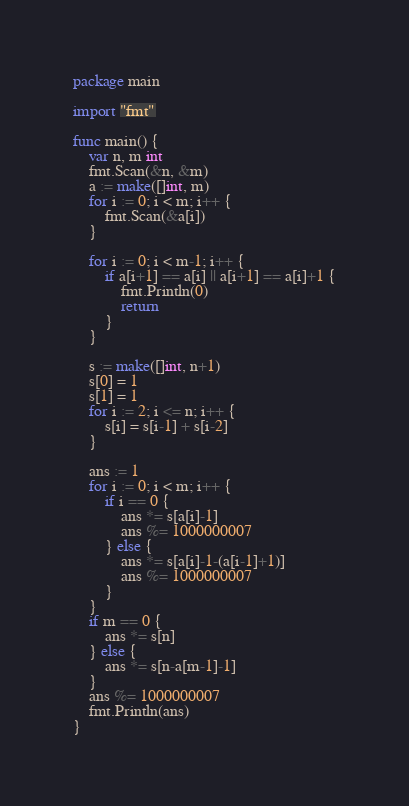Convert code to text. <code><loc_0><loc_0><loc_500><loc_500><_Go_>package main

import "fmt"

func main() {
	var n, m int
	fmt.Scan(&n, &m)
	a := make([]int, m)
	for i := 0; i < m; i++ {
		fmt.Scan(&a[i])
	}

	for i := 0; i < m-1; i++ {
		if a[i+1] == a[i] || a[i+1] == a[i]+1 {
			fmt.Println(0)
			return
		}
	}

	s := make([]int, n+1)
	s[0] = 1
	s[1] = 1
	for i := 2; i <= n; i++ {
		s[i] = s[i-1] + s[i-2]
	}

	ans := 1
	for i := 0; i < m; i++ {
		if i == 0 {
			ans *= s[a[i]-1]
			ans %= 1000000007
		} else {
			ans *= s[a[i]-1-(a[i-1]+1)]
			ans %= 1000000007
		}
	}
	if m == 0 {
		ans *= s[n]
	} else {
		ans *= s[n-a[m-1]-1]
	}
	ans %= 1000000007
	fmt.Println(ans)
}
</code> 